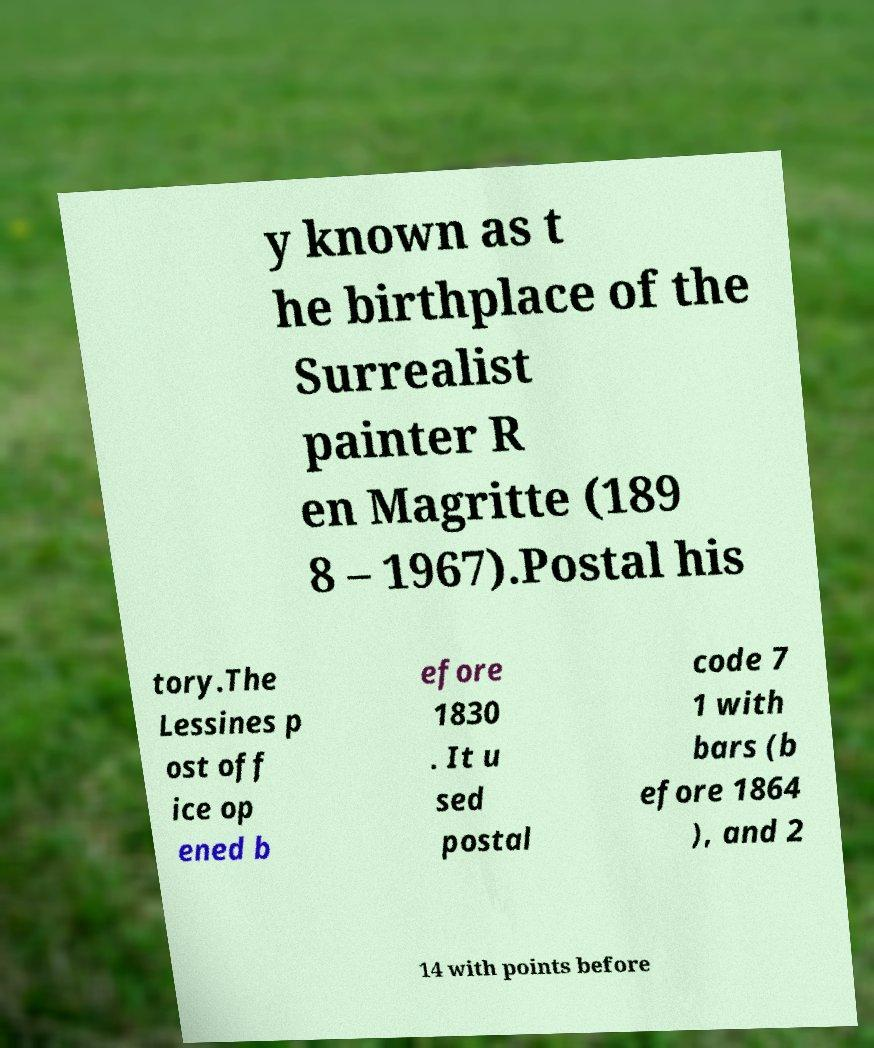I need the written content from this picture converted into text. Can you do that? y known as t he birthplace of the Surrealist painter R en Magritte (189 8 – 1967).Postal his tory.The Lessines p ost off ice op ened b efore 1830 . It u sed postal code 7 1 with bars (b efore 1864 ), and 2 14 with points before 